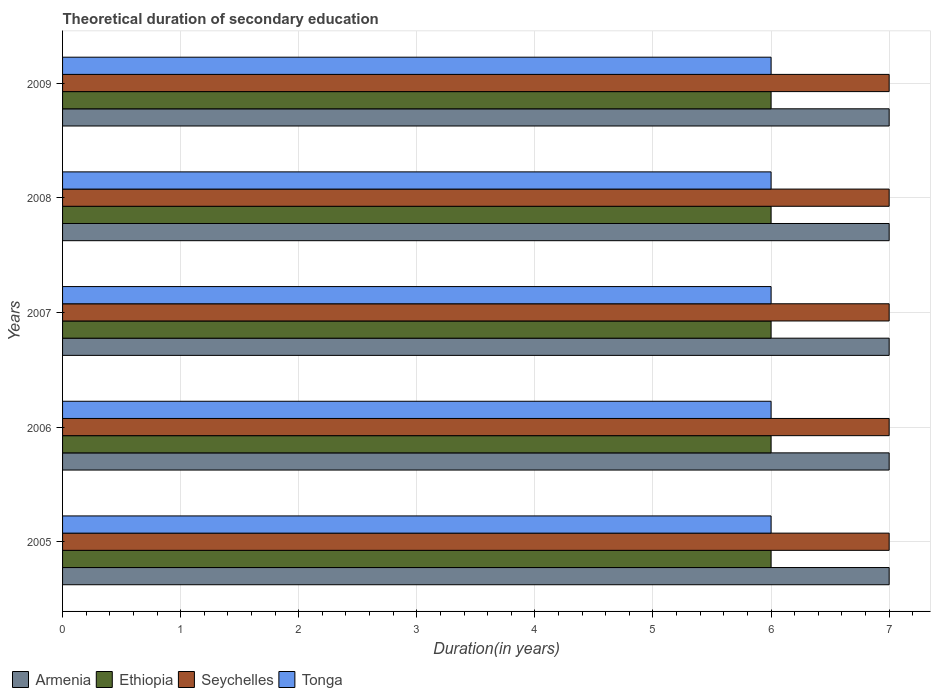Are the number of bars per tick equal to the number of legend labels?
Give a very brief answer. Yes. Are the number of bars on each tick of the Y-axis equal?
Keep it short and to the point. Yes. What is the label of the 2nd group of bars from the top?
Give a very brief answer. 2008. In how many cases, is the number of bars for a given year not equal to the number of legend labels?
Your response must be concise. 0. Across all years, what is the maximum total theoretical duration of secondary education in Seychelles?
Your answer should be compact. 7. Across all years, what is the minimum total theoretical duration of secondary education in Seychelles?
Provide a succinct answer. 7. In which year was the total theoretical duration of secondary education in Armenia maximum?
Your answer should be compact. 2005. What is the total total theoretical duration of secondary education in Seychelles in the graph?
Provide a short and direct response. 35. What is the difference between the total theoretical duration of secondary education in Tonga in 2006 and the total theoretical duration of secondary education in Armenia in 2007?
Your response must be concise. -1. In the year 2009, what is the difference between the total theoretical duration of secondary education in Ethiopia and total theoretical duration of secondary education in Armenia?
Your response must be concise. -1. In how many years, is the total theoretical duration of secondary education in Seychelles greater than 3.6 years?
Provide a succinct answer. 5. Is the total theoretical duration of secondary education in Seychelles in 2005 less than that in 2007?
Your response must be concise. No. What is the difference between the highest and the lowest total theoretical duration of secondary education in Tonga?
Provide a succinct answer. 0. What does the 1st bar from the top in 2009 represents?
Offer a very short reply. Tonga. What does the 3rd bar from the bottom in 2007 represents?
Offer a very short reply. Seychelles. How many bars are there?
Provide a succinct answer. 20. How many years are there in the graph?
Keep it short and to the point. 5. Does the graph contain any zero values?
Your answer should be compact. No. Does the graph contain grids?
Make the answer very short. Yes. Where does the legend appear in the graph?
Provide a succinct answer. Bottom left. What is the title of the graph?
Your response must be concise. Theoretical duration of secondary education. Does "Greenland" appear as one of the legend labels in the graph?
Give a very brief answer. No. What is the label or title of the X-axis?
Keep it short and to the point. Duration(in years). What is the Duration(in years) in Armenia in 2005?
Make the answer very short. 7. What is the Duration(in years) of Ethiopia in 2005?
Ensure brevity in your answer.  6. What is the Duration(in years) of Ethiopia in 2006?
Provide a succinct answer. 6. What is the Duration(in years) of Tonga in 2006?
Offer a terse response. 6. What is the Duration(in years) of Armenia in 2007?
Make the answer very short. 7. What is the Duration(in years) of Ethiopia in 2007?
Make the answer very short. 6. What is the Duration(in years) in Seychelles in 2007?
Provide a short and direct response. 7. What is the Duration(in years) of Ethiopia in 2009?
Your response must be concise. 6. What is the Duration(in years) of Seychelles in 2009?
Your answer should be very brief. 7. What is the Duration(in years) in Tonga in 2009?
Ensure brevity in your answer.  6. Across all years, what is the maximum Duration(in years) of Tonga?
Ensure brevity in your answer.  6. Across all years, what is the minimum Duration(in years) in Armenia?
Offer a terse response. 7. Across all years, what is the minimum Duration(in years) in Seychelles?
Your answer should be compact. 7. Across all years, what is the minimum Duration(in years) in Tonga?
Ensure brevity in your answer.  6. What is the total Duration(in years) of Armenia in the graph?
Your answer should be compact. 35. What is the difference between the Duration(in years) of Armenia in 2005 and that in 2006?
Provide a short and direct response. 0. What is the difference between the Duration(in years) of Tonga in 2005 and that in 2006?
Ensure brevity in your answer.  0. What is the difference between the Duration(in years) of Armenia in 2005 and that in 2007?
Offer a terse response. 0. What is the difference between the Duration(in years) in Seychelles in 2005 and that in 2008?
Your response must be concise. 0. What is the difference between the Duration(in years) in Ethiopia in 2005 and that in 2009?
Give a very brief answer. 0. What is the difference between the Duration(in years) in Tonga in 2005 and that in 2009?
Ensure brevity in your answer.  0. What is the difference between the Duration(in years) in Ethiopia in 2006 and that in 2007?
Provide a succinct answer. 0. What is the difference between the Duration(in years) of Tonga in 2006 and that in 2007?
Offer a terse response. 0. What is the difference between the Duration(in years) in Seychelles in 2006 and that in 2008?
Make the answer very short. 0. What is the difference between the Duration(in years) of Tonga in 2006 and that in 2008?
Provide a succinct answer. 0. What is the difference between the Duration(in years) of Ethiopia in 2006 and that in 2009?
Keep it short and to the point. 0. What is the difference between the Duration(in years) of Seychelles in 2006 and that in 2009?
Offer a terse response. 0. What is the difference between the Duration(in years) in Armenia in 2007 and that in 2008?
Your response must be concise. 0. What is the difference between the Duration(in years) in Ethiopia in 2007 and that in 2008?
Provide a short and direct response. 0. What is the difference between the Duration(in years) of Armenia in 2007 and that in 2009?
Ensure brevity in your answer.  0. What is the difference between the Duration(in years) in Tonga in 2007 and that in 2009?
Provide a succinct answer. 0. What is the difference between the Duration(in years) of Tonga in 2008 and that in 2009?
Offer a terse response. 0. What is the difference between the Duration(in years) in Armenia in 2005 and the Duration(in years) in Ethiopia in 2006?
Provide a short and direct response. 1. What is the difference between the Duration(in years) of Armenia in 2005 and the Duration(in years) of Tonga in 2007?
Your answer should be very brief. 1. What is the difference between the Duration(in years) of Ethiopia in 2005 and the Duration(in years) of Seychelles in 2007?
Offer a terse response. -1. What is the difference between the Duration(in years) of Seychelles in 2005 and the Duration(in years) of Tonga in 2007?
Give a very brief answer. 1. What is the difference between the Duration(in years) in Armenia in 2005 and the Duration(in years) in Ethiopia in 2008?
Give a very brief answer. 1. What is the difference between the Duration(in years) in Ethiopia in 2005 and the Duration(in years) in Seychelles in 2008?
Give a very brief answer. -1. What is the difference between the Duration(in years) in Ethiopia in 2005 and the Duration(in years) in Tonga in 2008?
Offer a very short reply. 0. What is the difference between the Duration(in years) in Armenia in 2005 and the Duration(in years) in Seychelles in 2009?
Your answer should be compact. 0. What is the difference between the Duration(in years) of Armenia in 2005 and the Duration(in years) of Tonga in 2009?
Your answer should be compact. 1. What is the difference between the Duration(in years) in Ethiopia in 2005 and the Duration(in years) in Seychelles in 2009?
Provide a short and direct response. -1. What is the difference between the Duration(in years) of Ethiopia in 2005 and the Duration(in years) of Tonga in 2009?
Offer a very short reply. 0. What is the difference between the Duration(in years) of Seychelles in 2005 and the Duration(in years) of Tonga in 2009?
Keep it short and to the point. 1. What is the difference between the Duration(in years) in Armenia in 2006 and the Duration(in years) in Tonga in 2007?
Give a very brief answer. 1. What is the difference between the Duration(in years) in Ethiopia in 2006 and the Duration(in years) in Seychelles in 2007?
Keep it short and to the point. -1. What is the difference between the Duration(in years) in Ethiopia in 2006 and the Duration(in years) in Tonga in 2007?
Give a very brief answer. 0. What is the difference between the Duration(in years) of Armenia in 2006 and the Duration(in years) of Ethiopia in 2008?
Provide a short and direct response. 1. What is the difference between the Duration(in years) in Armenia in 2006 and the Duration(in years) in Tonga in 2008?
Provide a succinct answer. 1. What is the difference between the Duration(in years) of Ethiopia in 2006 and the Duration(in years) of Tonga in 2008?
Ensure brevity in your answer.  0. What is the difference between the Duration(in years) in Seychelles in 2006 and the Duration(in years) in Tonga in 2008?
Offer a very short reply. 1. What is the difference between the Duration(in years) in Armenia in 2006 and the Duration(in years) in Ethiopia in 2009?
Your response must be concise. 1. What is the difference between the Duration(in years) in Armenia in 2006 and the Duration(in years) in Seychelles in 2009?
Ensure brevity in your answer.  0. What is the difference between the Duration(in years) of Armenia in 2006 and the Duration(in years) of Tonga in 2009?
Your response must be concise. 1. What is the difference between the Duration(in years) of Seychelles in 2006 and the Duration(in years) of Tonga in 2009?
Give a very brief answer. 1. What is the difference between the Duration(in years) of Armenia in 2007 and the Duration(in years) of Ethiopia in 2008?
Your answer should be compact. 1. What is the difference between the Duration(in years) of Armenia in 2007 and the Duration(in years) of Seychelles in 2008?
Make the answer very short. 0. What is the difference between the Duration(in years) of Armenia in 2007 and the Duration(in years) of Tonga in 2008?
Give a very brief answer. 1. What is the difference between the Duration(in years) in Ethiopia in 2007 and the Duration(in years) in Seychelles in 2008?
Offer a very short reply. -1. What is the difference between the Duration(in years) in Ethiopia in 2007 and the Duration(in years) in Tonga in 2008?
Your answer should be compact. 0. What is the difference between the Duration(in years) in Armenia in 2007 and the Duration(in years) in Tonga in 2009?
Make the answer very short. 1. What is the difference between the Duration(in years) of Ethiopia in 2007 and the Duration(in years) of Tonga in 2009?
Your answer should be very brief. 0. What is the difference between the Duration(in years) of Armenia in 2008 and the Duration(in years) of Ethiopia in 2009?
Make the answer very short. 1. What is the difference between the Duration(in years) in Armenia in 2008 and the Duration(in years) in Seychelles in 2009?
Provide a short and direct response. 0. What is the difference between the Duration(in years) in Armenia in 2008 and the Duration(in years) in Tonga in 2009?
Provide a short and direct response. 1. What is the average Duration(in years) of Armenia per year?
Provide a succinct answer. 7. What is the average Duration(in years) in Ethiopia per year?
Provide a short and direct response. 6. What is the average Duration(in years) of Tonga per year?
Provide a succinct answer. 6. In the year 2005, what is the difference between the Duration(in years) in Armenia and Duration(in years) in Ethiopia?
Ensure brevity in your answer.  1. In the year 2005, what is the difference between the Duration(in years) of Armenia and Duration(in years) of Tonga?
Your response must be concise. 1. In the year 2006, what is the difference between the Duration(in years) of Armenia and Duration(in years) of Seychelles?
Offer a terse response. 0. In the year 2006, what is the difference between the Duration(in years) of Seychelles and Duration(in years) of Tonga?
Provide a short and direct response. 1. In the year 2007, what is the difference between the Duration(in years) in Armenia and Duration(in years) in Ethiopia?
Your answer should be compact. 1. In the year 2007, what is the difference between the Duration(in years) in Armenia and Duration(in years) in Seychelles?
Your response must be concise. 0. In the year 2007, what is the difference between the Duration(in years) of Seychelles and Duration(in years) of Tonga?
Offer a terse response. 1. In the year 2008, what is the difference between the Duration(in years) of Armenia and Duration(in years) of Ethiopia?
Provide a short and direct response. 1. In the year 2008, what is the difference between the Duration(in years) of Ethiopia and Duration(in years) of Seychelles?
Keep it short and to the point. -1. In the year 2008, what is the difference between the Duration(in years) of Seychelles and Duration(in years) of Tonga?
Your response must be concise. 1. In the year 2009, what is the difference between the Duration(in years) of Armenia and Duration(in years) of Ethiopia?
Your response must be concise. 1. In the year 2009, what is the difference between the Duration(in years) of Armenia and Duration(in years) of Seychelles?
Keep it short and to the point. 0. In the year 2009, what is the difference between the Duration(in years) of Armenia and Duration(in years) of Tonga?
Provide a succinct answer. 1. What is the ratio of the Duration(in years) of Armenia in 2005 to that in 2006?
Provide a succinct answer. 1. What is the ratio of the Duration(in years) in Seychelles in 2005 to that in 2006?
Provide a short and direct response. 1. What is the ratio of the Duration(in years) of Tonga in 2005 to that in 2006?
Offer a terse response. 1. What is the ratio of the Duration(in years) of Seychelles in 2005 to that in 2007?
Offer a terse response. 1. What is the ratio of the Duration(in years) in Ethiopia in 2005 to that in 2008?
Make the answer very short. 1. What is the ratio of the Duration(in years) in Seychelles in 2005 to that in 2008?
Your response must be concise. 1. What is the ratio of the Duration(in years) of Armenia in 2005 to that in 2009?
Provide a succinct answer. 1. What is the ratio of the Duration(in years) of Tonga in 2005 to that in 2009?
Offer a very short reply. 1. What is the ratio of the Duration(in years) in Tonga in 2006 to that in 2007?
Your answer should be compact. 1. What is the ratio of the Duration(in years) in Armenia in 2006 to that in 2008?
Your answer should be compact. 1. What is the ratio of the Duration(in years) of Ethiopia in 2006 to that in 2008?
Your answer should be compact. 1. What is the ratio of the Duration(in years) in Seychelles in 2006 to that in 2008?
Make the answer very short. 1. What is the ratio of the Duration(in years) of Armenia in 2006 to that in 2009?
Offer a very short reply. 1. What is the ratio of the Duration(in years) in Seychelles in 2006 to that in 2009?
Ensure brevity in your answer.  1. What is the ratio of the Duration(in years) of Ethiopia in 2007 to that in 2008?
Your response must be concise. 1. What is the ratio of the Duration(in years) in Tonga in 2007 to that in 2008?
Your answer should be compact. 1. What is the ratio of the Duration(in years) in Armenia in 2007 to that in 2009?
Offer a very short reply. 1. What is the ratio of the Duration(in years) in Seychelles in 2007 to that in 2009?
Your answer should be compact. 1. What is the ratio of the Duration(in years) in Seychelles in 2008 to that in 2009?
Keep it short and to the point. 1. What is the difference between the highest and the second highest Duration(in years) in Ethiopia?
Offer a terse response. 0. What is the difference between the highest and the second highest Duration(in years) in Seychelles?
Provide a short and direct response. 0. What is the difference between the highest and the second highest Duration(in years) in Tonga?
Give a very brief answer. 0. What is the difference between the highest and the lowest Duration(in years) in Armenia?
Keep it short and to the point. 0. 